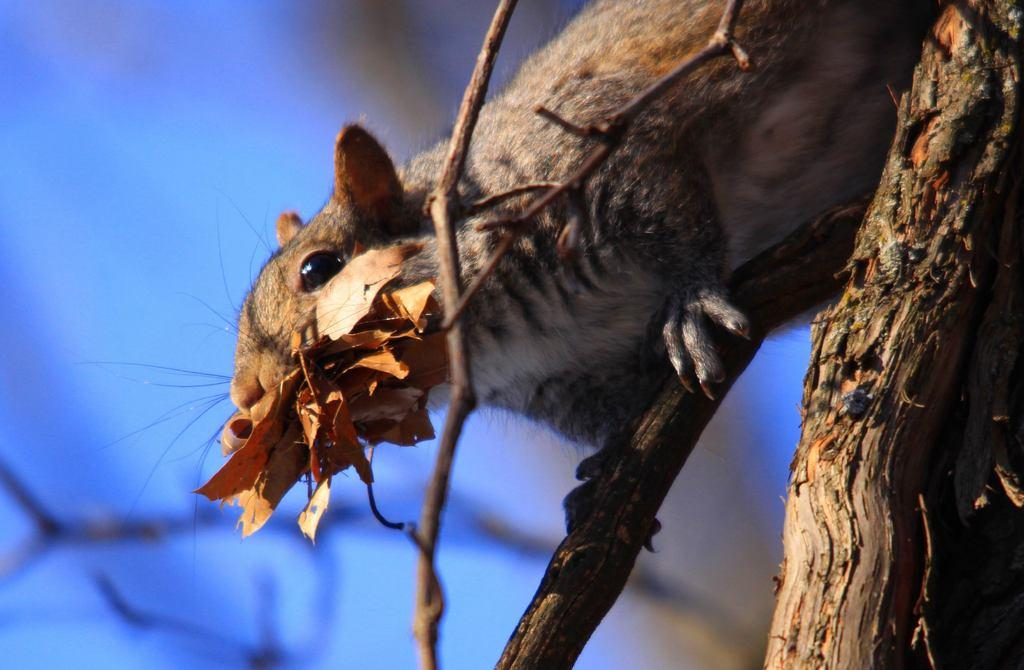What is the main subject of the image? There is an animal in the image. What is the animal doing in the image? The animal is eating dry leaves. Where is the animal located in the image? The animal is on a tree branch. Can you describe the background of the image? The background of the image is blurred, and the background color is blue. What type of society is depicted in the image? There is no society depicted in the image; it features an animal eating dry leaves on a tree branch. What industry is represented in the image? There is no industry represented in the image; it focuses on a single animal in a natural setting. 